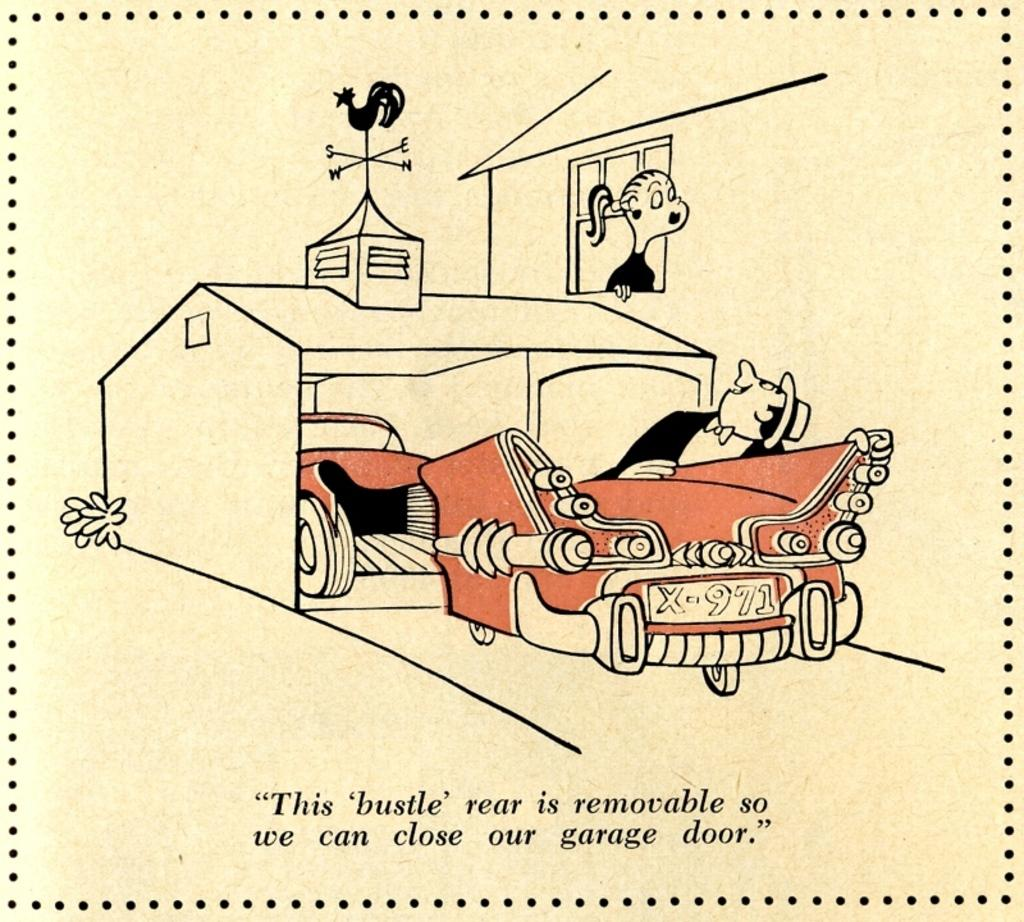What type of image is present in the picture? There is a cartoon image in the picture. What objects are included in the cartoon image? The cartoon image contains a car and a house. How many people are depicted in the cartoon image? There are two persons in the cartoon image. Is there any text present on the picture? Yes, there is text written on the picture. What type of liquid can be seen flowing from the truck in the image? There is no truck present in the image, so there is no liquid flowing from it. 